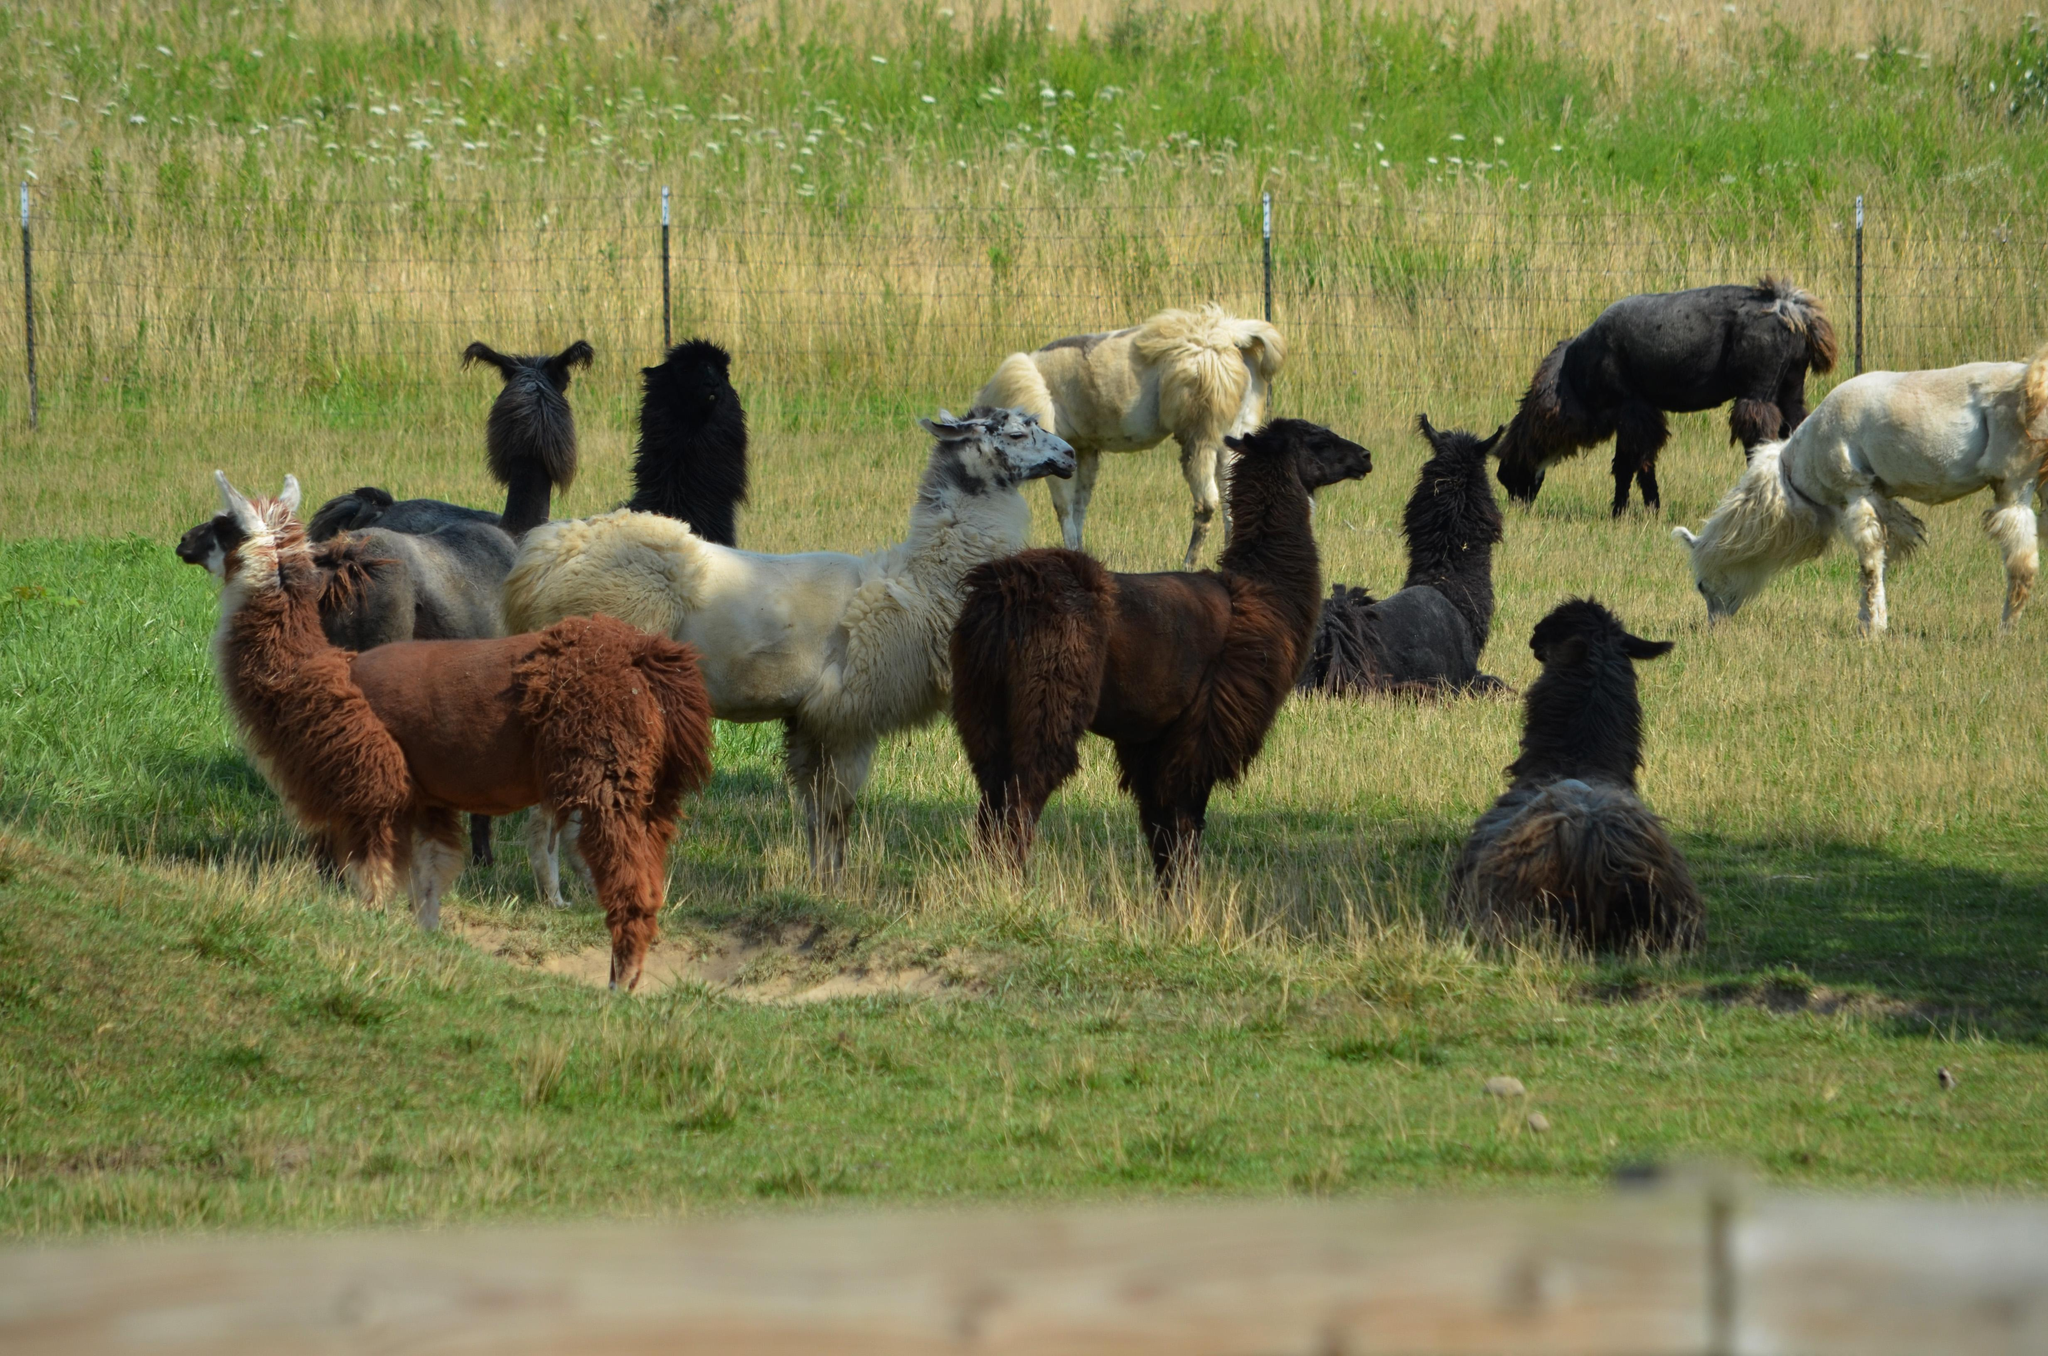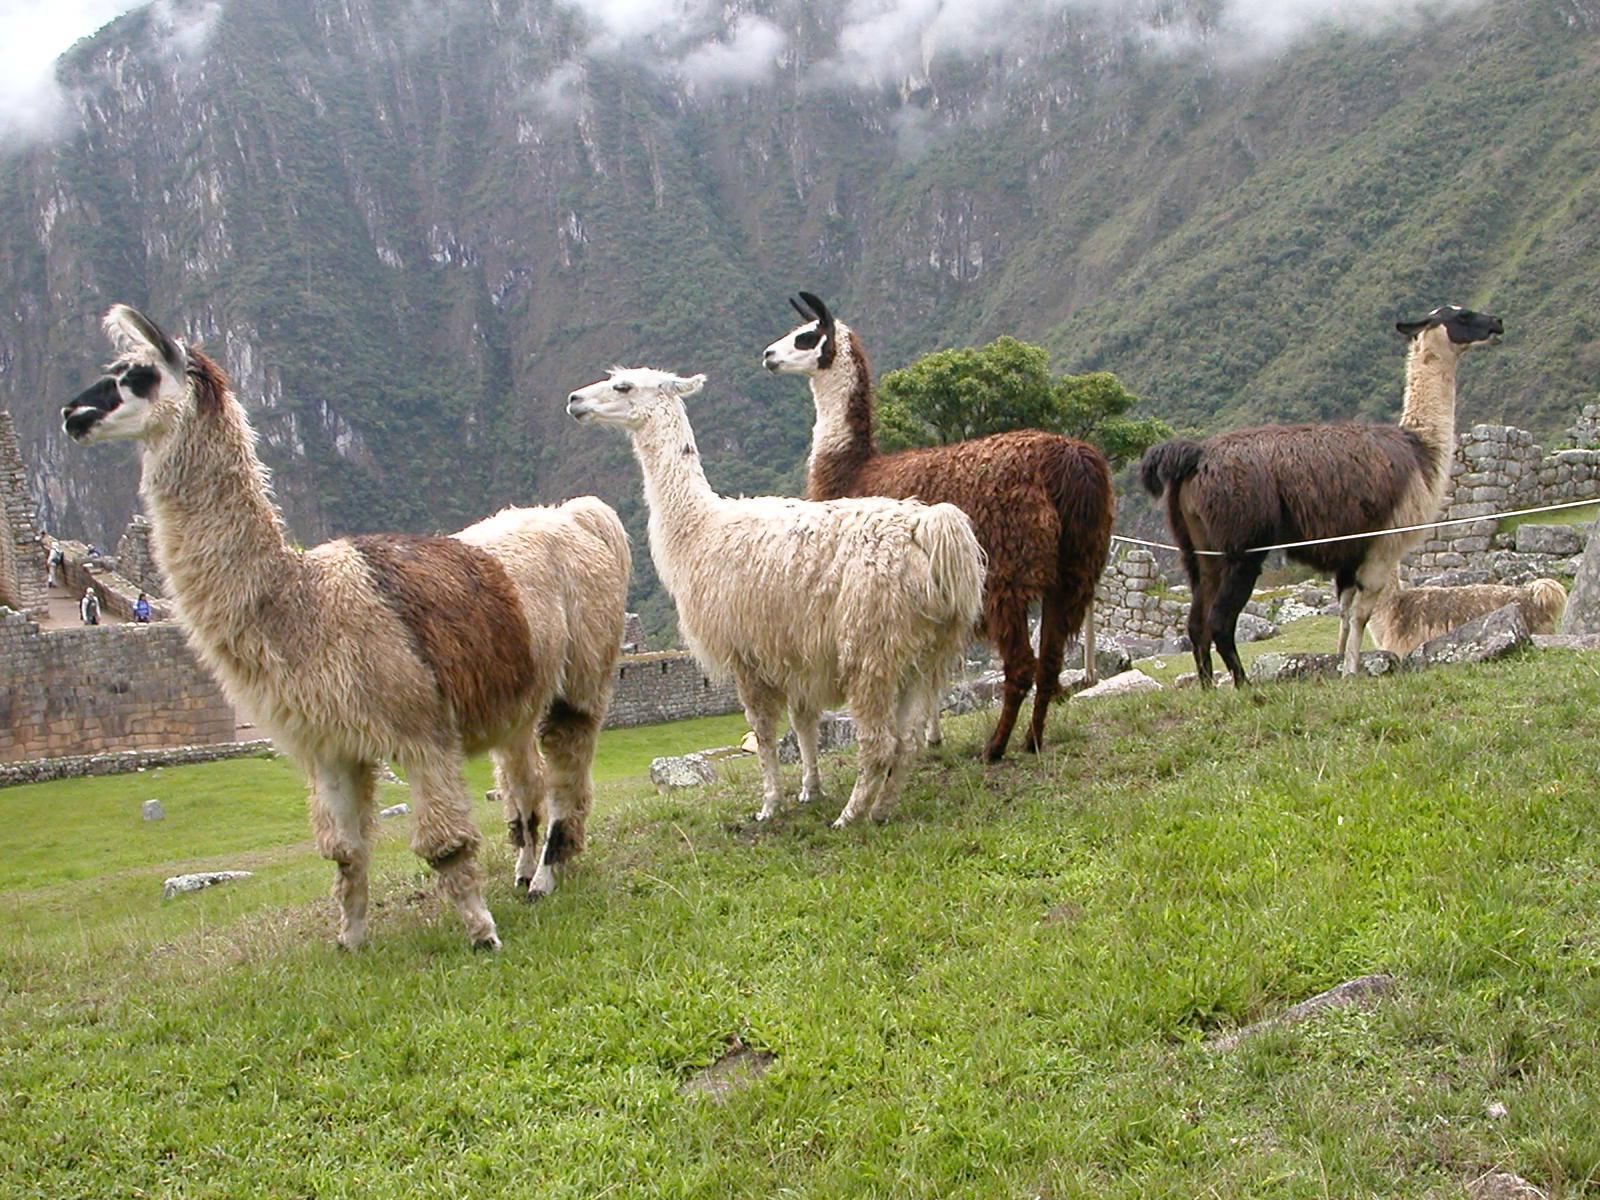The first image is the image on the left, the second image is the image on the right. Considering the images on both sides, is "Each image includes at least four llamas, and no image shows a group of forward-facing llamas." valid? Answer yes or no. Yes. The first image is the image on the left, the second image is the image on the right. Assess this claim about the two images: "In the image to the right, there are fewer than ten llamas.". Correct or not? Answer yes or no. Yes. 